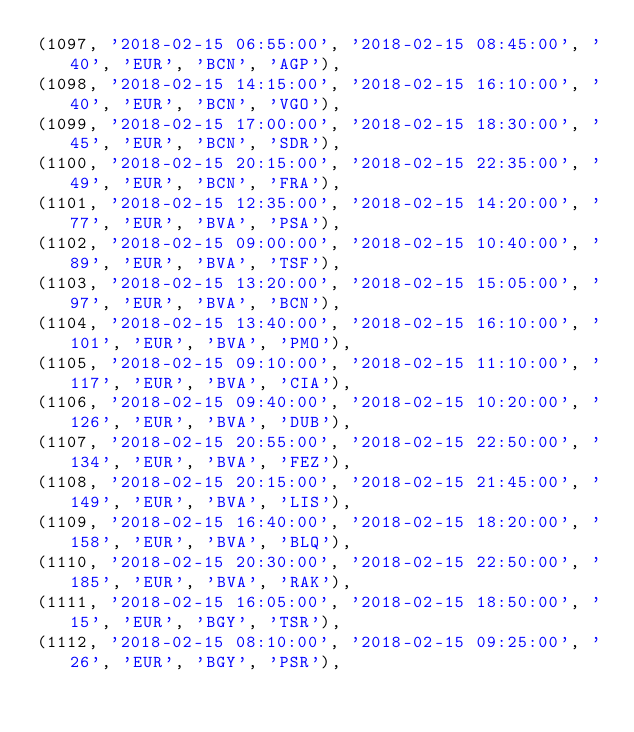<code> <loc_0><loc_0><loc_500><loc_500><_SQL_>(1097, '2018-02-15 06:55:00', '2018-02-15 08:45:00', '40', 'EUR', 'BCN', 'AGP'),
(1098, '2018-02-15 14:15:00', '2018-02-15 16:10:00', '40', 'EUR', 'BCN', 'VGO'),
(1099, '2018-02-15 17:00:00', '2018-02-15 18:30:00', '45', 'EUR', 'BCN', 'SDR'),
(1100, '2018-02-15 20:15:00', '2018-02-15 22:35:00', '49', 'EUR', 'BCN', 'FRA'),
(1101, '2018-02-15 12:35:00', '2018-02-15 14:20:00', '77', 'EUR', 'BVA', 'PSA'),
(1102, '2018-02-15 09:00:00', '2018-02-15 10:40:00', '89', 'EUR', 'BVA', 'TSF'),
(1103, '2018-02-15 13:20:00', '2018-02-15 15:05:00', '97', 'EUR', 'BVA', 'BCN'),
(1104, '2018-02-15 13:40:00', '2018-02-15 16:10:00', '101', 'EUR', 'BVA', 'PMO'),
(1105, '2018-02-15 09:10:00', '2018-02-15 11:10:00', '117', 'EUR', 'BVA', 'CIA'),
(1106, '2018-02-15 09:40:00', '2018-02-15 10:20:00', '126', 'EUR', 'BVA', 'DUB'),
(1107, '2018-02-15 20:55:00', '2018-02-15 22:50:00', '134', 'EUR', 'BVA', 'FEZ'),
(1108, '2018-02-15 20:15:00', '2018-02-15 21:45:00', '149', 'EUR', 'BVA', 'LIS'),
(1109, '2018-02-15 16:40:00', '2018-02-15 18:20:00', '158', 'EUR', 'BVA', 'BLQ'),
(1110, '2018-02-15 20:30:00', '2018-02-15 22:50:00', '185', 'EUR', 'BVA', 'RAK'),
(1111, '2018-02-15 16:05:00', '2018-02-15 18:50:00', '15', 'EUR', 'BGY', 'TSR'),
(1112, '2018-02-15 08:10:00', '2018-02-15 09:25:00', '26', 'EUR', 'BGY', 'PSR'),</code> 